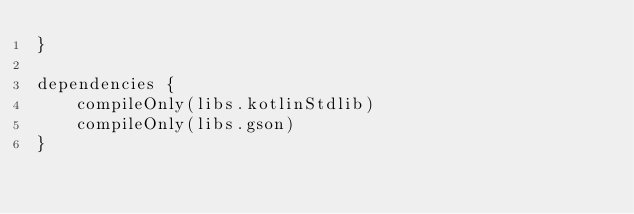Convert code to text. <code><loc_0><loc_0><loc_500><loc_500><_Kotlin_>}

dependencies {
    compileOnly(libs.kotlinStdlib)
    compileOnly(libs.gson)
}
</code> 